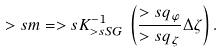Convert formula to latex. <formula><loc_0><loc_0><loc_500><loc_500>> s m = > s K _ { > s S G } ^ { - 1 } \, \left ( \frac { > s q _ { \varphi } } { > s q _ { \zeta } } \Delta \zeta \right ) .</formula> 